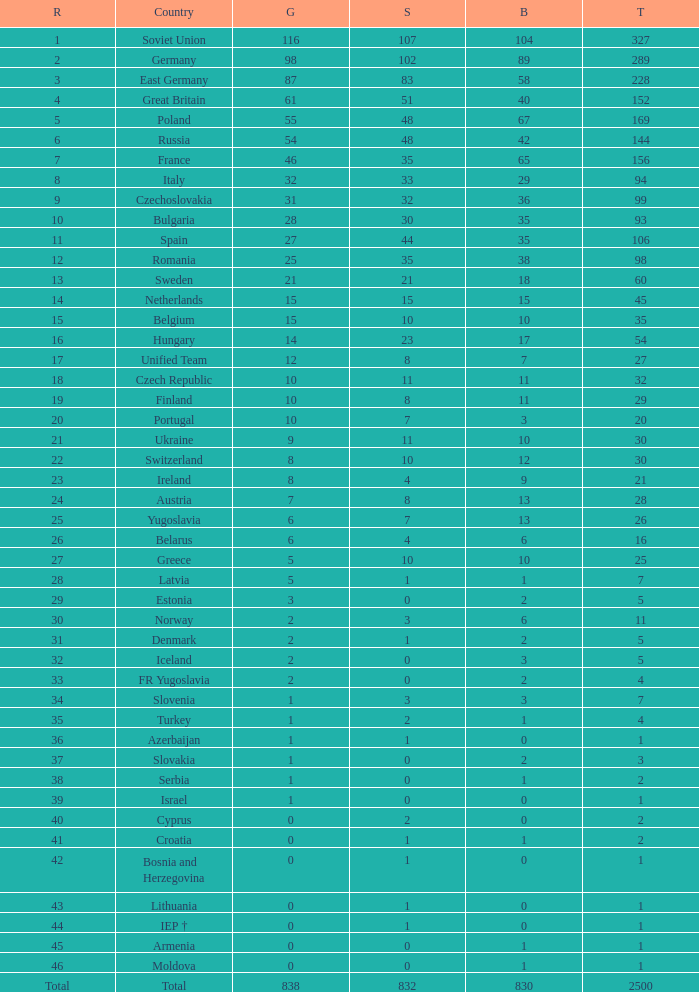What is the rank of the nation with more than 0 silver medals and 38 bronze medals? 12.0. 